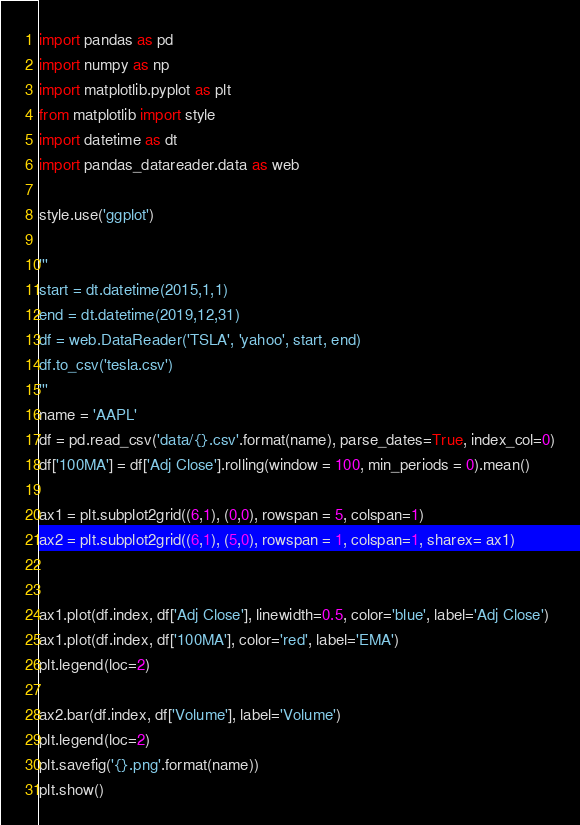<code> <loc_0><loc_0><loc_500><loc_500><_Python_>import pandas as pd
import numpy as np
import matplotlib.pyplot as plt
from matplotlib import style
import datetime as dt
import pandas_datareader.data as web

style.use('ggplot')

'''
start = dt.datetime(2015,1,1)
end = dt.datetime(2019,12,31)
df = web.DataReader('TSLA', 'yahoo', start, end)
df.to_csv('tesla.csv')
'''
name = 'AAPL'
df = pd.read_csv('data/{}.csv'.format(name), parse_dates=True, index_col=0)
df['100MA'] = df['Adj Close'].rolling(window = 100, min_periods = 0).mean()

ax1 = plt.subplot2grid((6,1), (0,0), rowspan = 5, colspan=1)
ax2 = plt.subplot2grid((6,1), (5,0), rowspan = 1, colspan=1, sharex= ax1)


ax1.plot(df.index, df['Adj Close'], linewidth=0.5, color='blue', label='Adj Close')
ax1.plot(df.index, df['100MA'], color='red', label='EMA')
plt.legend(loc=2)

ax2.bar(df.index, df['Volume'], label='Volume')
plt.legend(loc=2)
plt.savefig('{}.png'.format(name))
plt.show()
</code> 